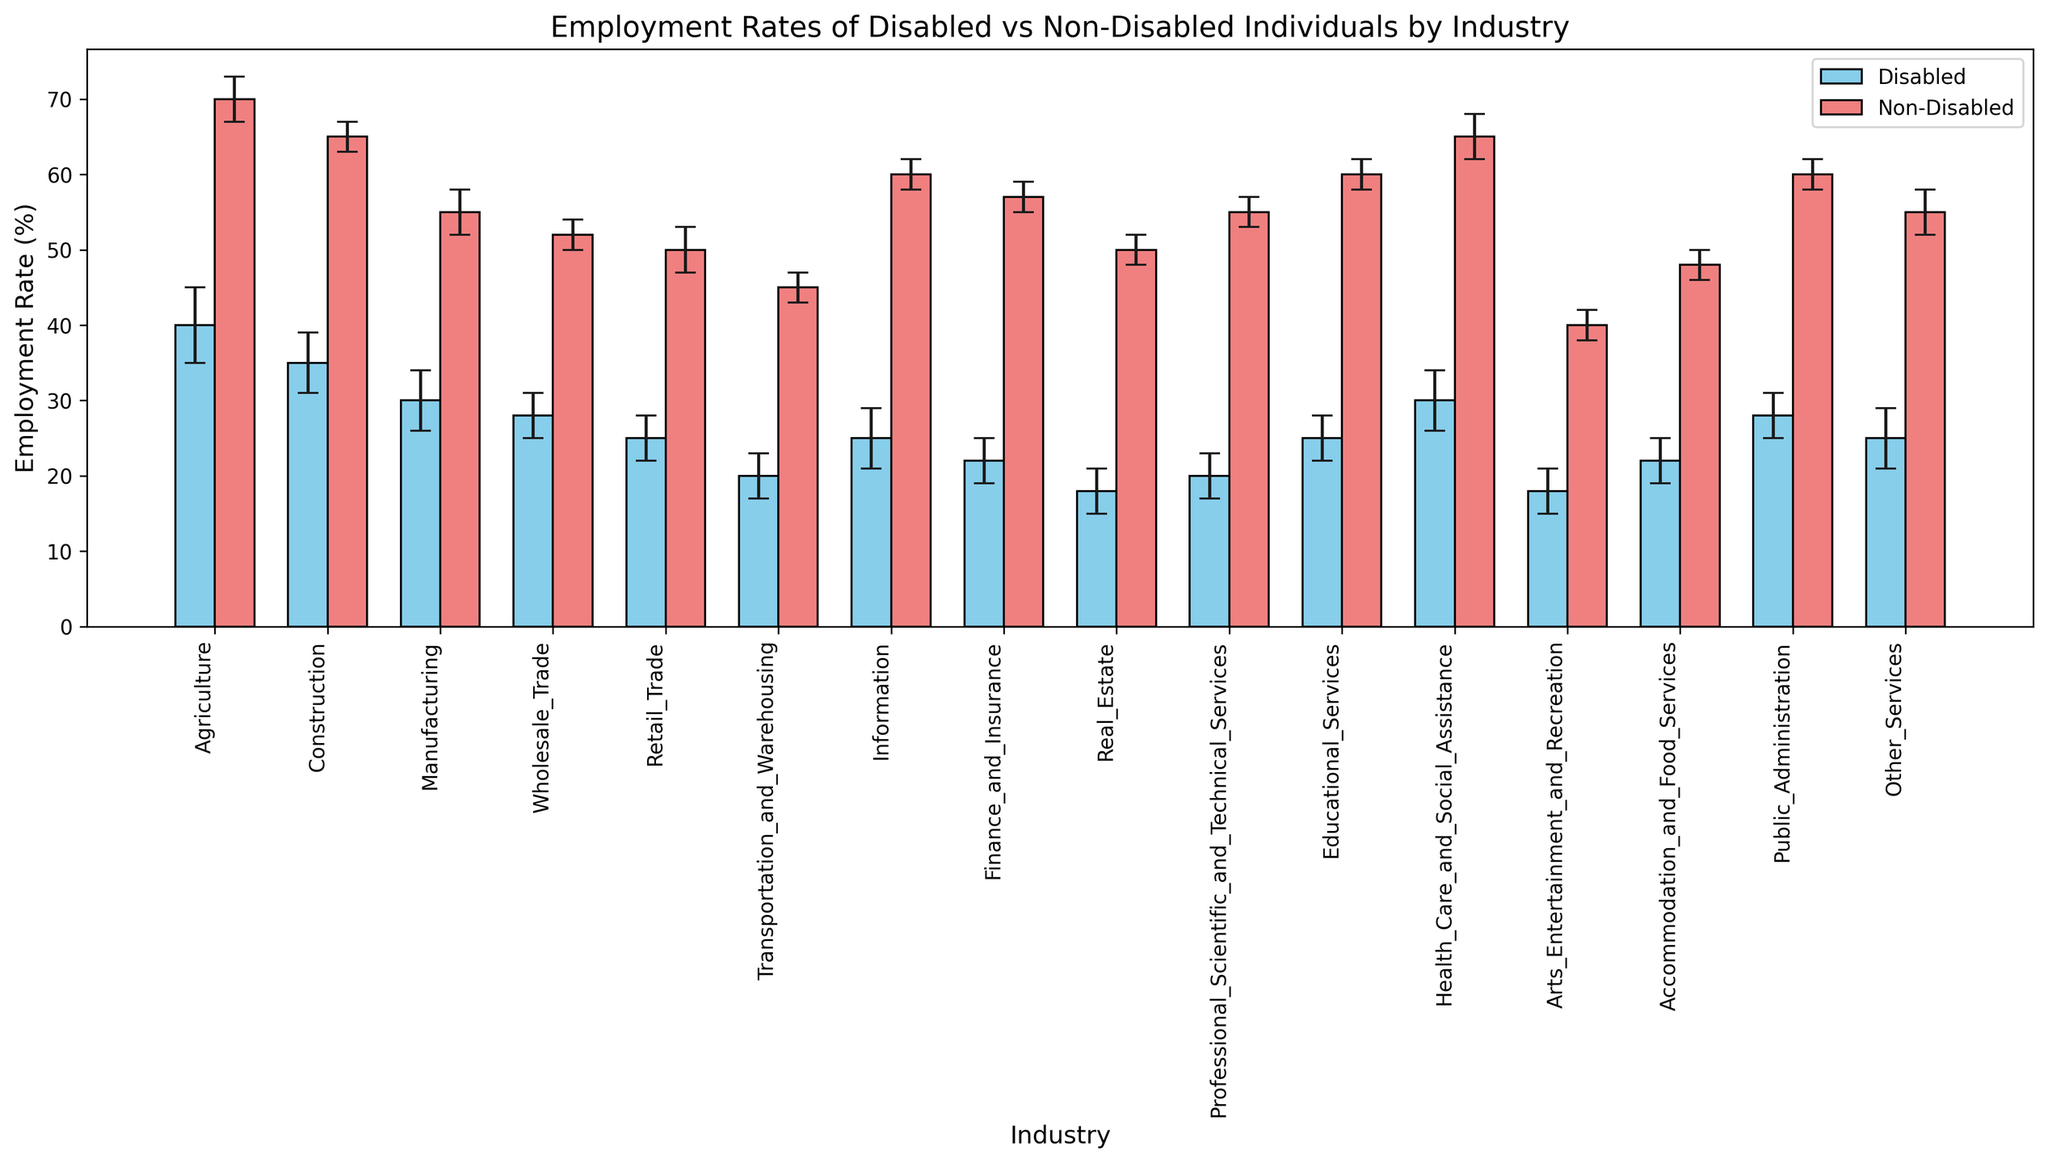Which industry has the highest employment rate for disabled individuals? The highest bar among the disabled individuals is for the Agriculture industry at 40%.
Answer: Agriculture What is the difference in employment rates between disabled and non-disabled individuals in the Construction industry? The employment rate for disabled individuals in Construction is 35%, and for non-disabled individuals, it is 65%. The difference is 65% - 35% = 30%.
Answer: 30% In which industry is the employment rate for disabled individuals closest to the employment rate of non-disabled individuals? By visually comparing the bars and the error bars across industries, the Information industry shows the closest rates: 25% for disabled and 60% for non-disabled, but visually they are not very close due to large difference.
Answer: None are close (significant gaps) Which industry shows the largest gap in employment rates between disabled and non-disabled individuals? The largest visual gap between the bars is in the Agriculture industry with disabled individuals at 40% and non-disabled at 70%, making the gap 70% - 40% = 30%.
Answer: Agriculture Considering the error bars, can we definitively state that disabled individuals have lower employment rates than non-disabled individuals across all industries? Although there is overlap in the error bars in some industries, like Information and Wholesale Trade, in general, disabled employment rates are visually lower than non-disabled rates across all industries.
Answer: Yes What is the average employment rate for disabled individuals across all industries? To calculate the average: (40 + 35 + 30 + 28 + 25 + 20 + 25 + 22 + 18 + 20 + 25 + 30 + 18 + 22 + 28 + 25) / 16 = 25%.
Answer: 25% In which industry do non-disabled individuals have the highest employment rate? The highest bar among non-disabled individuals is for the Agriculture industry at 70%.
Answer: Agriculture What is the difference in error margins between disabled and non-disabled individuals in the Health Care and Social Assistance industry? The error margin for disabled individuals in Health Care and Social Assistance is 4%, and for non-disabled individuals, it is 3%. The difference is 4% - 3% = 1%.
Answer: 1% Which industry has the smallest difference in employment rates between disabled and non-disabled individuals? The smallest visual difference can be seen in the Wholesale Trade industry, with rates of 28% for disabled and 52% for non-disabled, resulting in a difference of 24%.
Answer: Wholesale Trade What is the average employment rate for non-disabled individuals in the Manufacturing, Wholesale Trade, and Retail Trade industries combined? To calculate the average employment rate for non-disabled individuals in these three industries: (55 + 52 + 50) / 3 = 52.33%.
Answer: 52.33% 